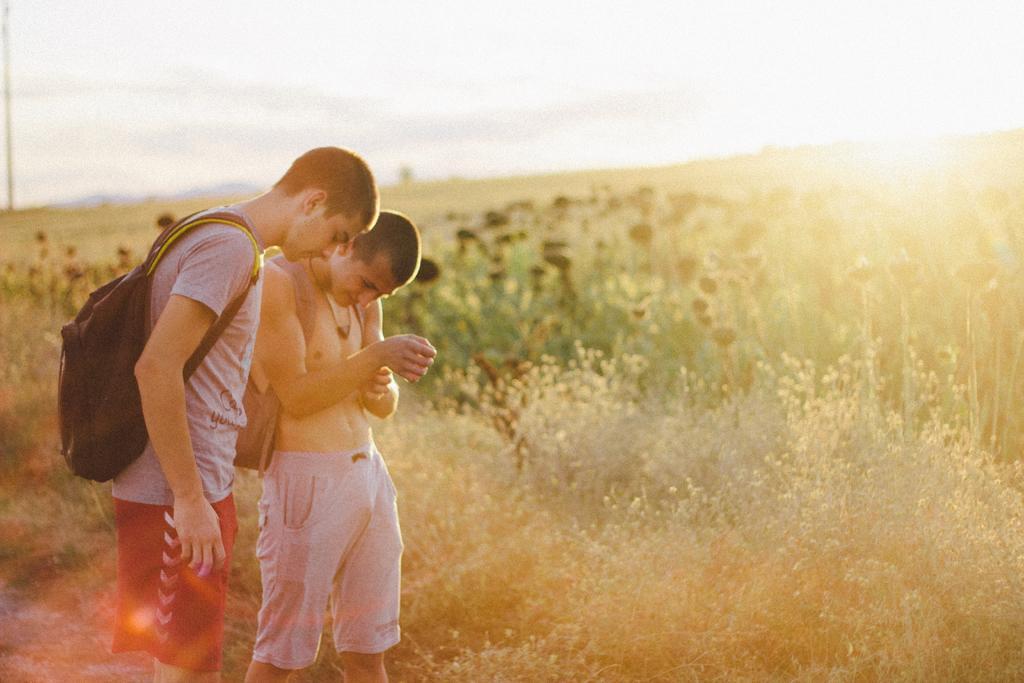Could you give a brief overview of what you see in this image? In this image I can see two men are standing in the front and I can see both of them are carrying bags. I can also see both of them are wearing shorts and one of them is wearing grey colour t shirt. In the background I can see planets, the sun and the sky. I can also see this image is little bit blurry in the background. 